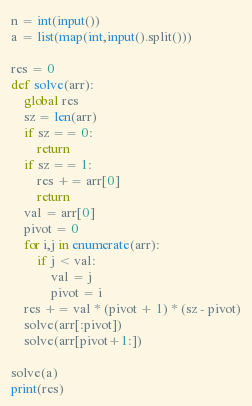Convert code to text. <code><loc_0><loc_0><loc_500><loc_500><_Python_>n = int(input())
a = list(map(int,input().split()))

res = 0
def solve(arr):
    global res
    sz = len(arr)
    if sz == 0:
        return
    if sz == 1:
        res += arr[0]
        return
    val = arr[0]
    pivot = 0
    for i,j in enumerate(arr):
        if j < val:
            val = j
            pivot = i
    res += val * (pivot + 1) * (sz - pivot)
    solve(arr[:pivot])
    solve(arr[pivot+1:])

solve(a)
print(res)
</code> 